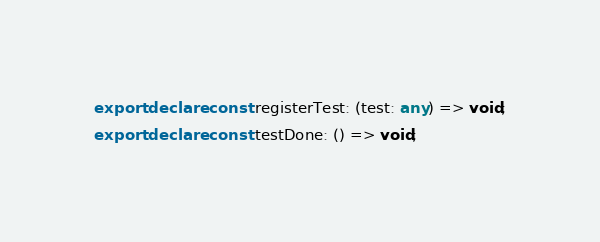Convert code to text. <code><loc_0><loc_0><loc_500><loc_500><_TypeScript_>export declare const registerTest: (test: any) => void;
export declare const testDone: () => void;
</code> 